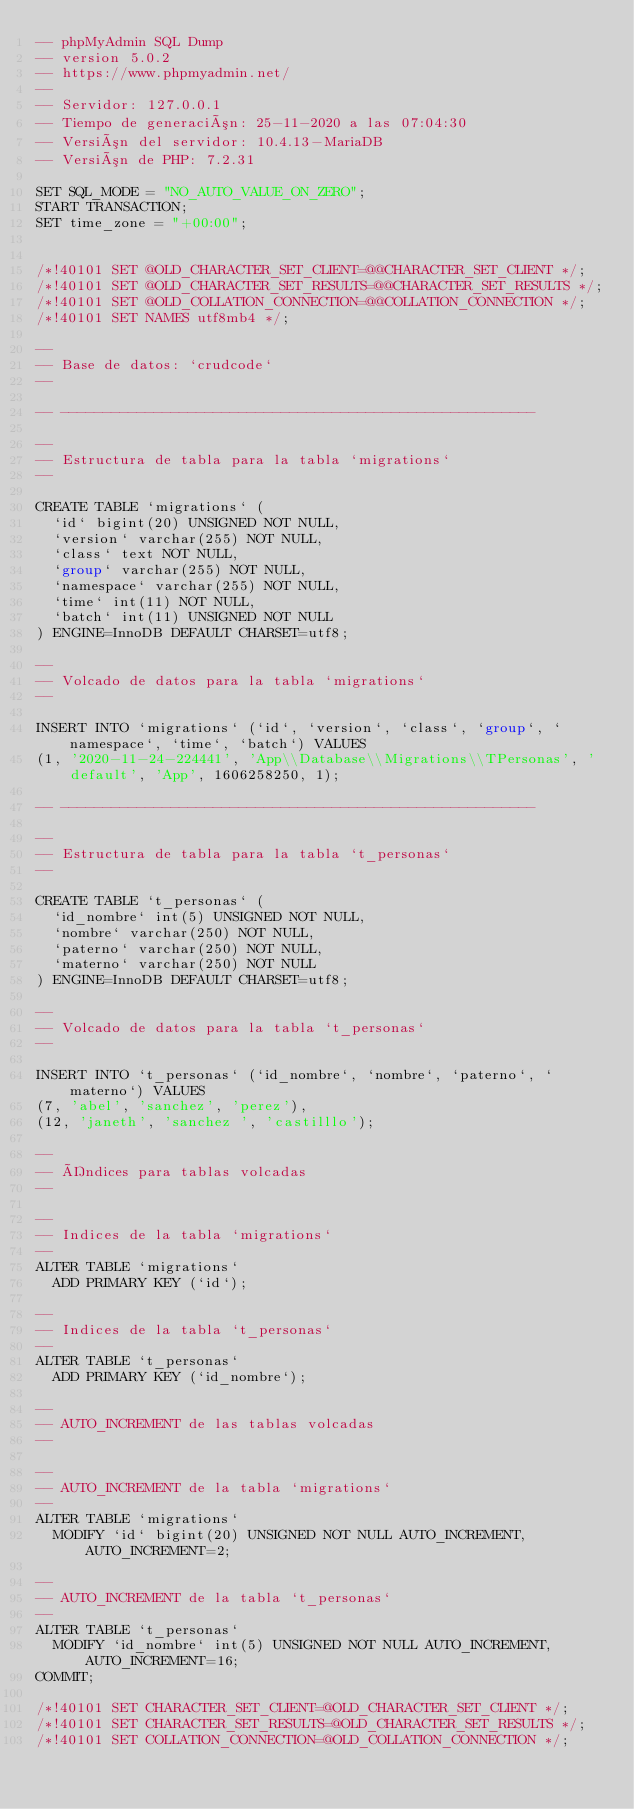Convert code to text. <code><loc_0><loc_0><loc_500><loc_500><_SQL_>-- phpMyAdmin SQL Dump
-- version 5.0.2
-- https://www.phpmyadmin.net/
--
-- Servidor: 127.0.0.1
-- Tiempo de generación: 25-11-2020 a las 07:04:30
-- Versión del servidor: 10.4.13-MariaDB
-- Versión de PHP: 7.2.31

SET SQL_MODE = "NO_AUTO_VALUE_ON_ZERO";
START TRANSACTION;
SET time_zone = "+00:00";


/*!40101 SET @OLD_CHARACTER_SET_CLIENT=@@CHARACTER_SET_CLIENT */;
/*!40101 SET @OLD_CHARACTER_SET_RESULTS=@@CHARACTER_SET_RESULTS */;
/*!40101 SET @OLD_COLLATION_CONNECTION=@@COLLATION_CONNECTION */;
/*!40101 SET NAMES utf8mb4 */;

--
-- Base de datos: `crudcode`
--

-- --------------------------------------------------------

--
-- Estructura de tabla para la tabla `migrations`
--

CREATE TABLE `migrations` (
  `id` bigint(20) UNSIGNED NOT NULL,
  `version` varchar(255) NOT NULL,
  `class` text NOT NULL,
  `group` varchar(255) NOT NULL,
  `namespace` varchar(255) NOT NULL,
  `time` int(11) NOT NULL,
  `batch` int(11) UNSIGNED NOT NULL
) ENGINE=InnoDB DEFAULT CHARSET=utf8;

--
-- Volcado de datos para la tabla `migrations`
--

INSERT INTO `migrations` (`id`, `version`, `class`, `group`, `namespace`, `time`, `batch`) VALUES
(1, '2020-11-24-224441', 'App\\Database\\Migrations\\TPersonas', 'default', 'App', 1606258250, 1);

-- --------------------------------------------------------

--
-- Estructura de tabla para la tabla `t_personas`
--

CREATE TABLE `t_personas` (
  `id_nombre` int(5) UNSIGNED NOT NULL,
  `nombre` varchar(250) NOT NULL,
  `paterno` varchar(250) NOT NULL,
  `materno` varchar(250) NOT NULL
) ENGINE=InnoDB DEFAULT CHARSET=utf8;

--
-- Volcado de datos para la tabla `t_personas`
--

INSERT INTO `t_personas` (`id_nombre`, `nombre`, `paterno`, `materno`) VALUES
(7, 'abel', 'sanchez', 'perez'),
(12, 'janeth', 'sanchez ', 'castilllo');

--
-- Índices para tablas volcadas
--

--
-- Indices de la tabla `migrations`
--
ALTER TABLE `migrations`
  ADD PRIMARY KEY (`id`);

--
-- Indices de la tabla `t_personas`
--
ALTER TABLE `t_personas`
  ADD PRIMARY KEY (`id_nombre`);

--
-- AUTO_INCREMENT de las tablas volcadas
--

--
-- AUTO_INCREMENT de la tabla `migrations`
--
ALTER TABLE `migrations`
  MODIFY `id` bigint(20) UNSIGNED NOT NULL AUTO_INCREMENT, AUTO_INCREMENT=2;

--
-- AUTO_INCREMENT de la tabla `t_personas`
--
ALTER TABLE `t_personas`
  MODIFY `id_nombre` int(5) UNSIGNED NOT NULL AUTO_INCREMENT, AUTO_INCREMENT=16;
COMMIT;

/*!40101 SET CHARACTER_SET_CLIENT=@OLD_CHARACTER_SET_CLIENT */;
/*!40101 SET CHARACTER_SET_RESULTS=@OLD_CHARACTER_SET_RESULTS */;
/*!40101 SET COLLATION_CONNECTION=@OLD_COLLATION_CONNECTION */;
</code> 